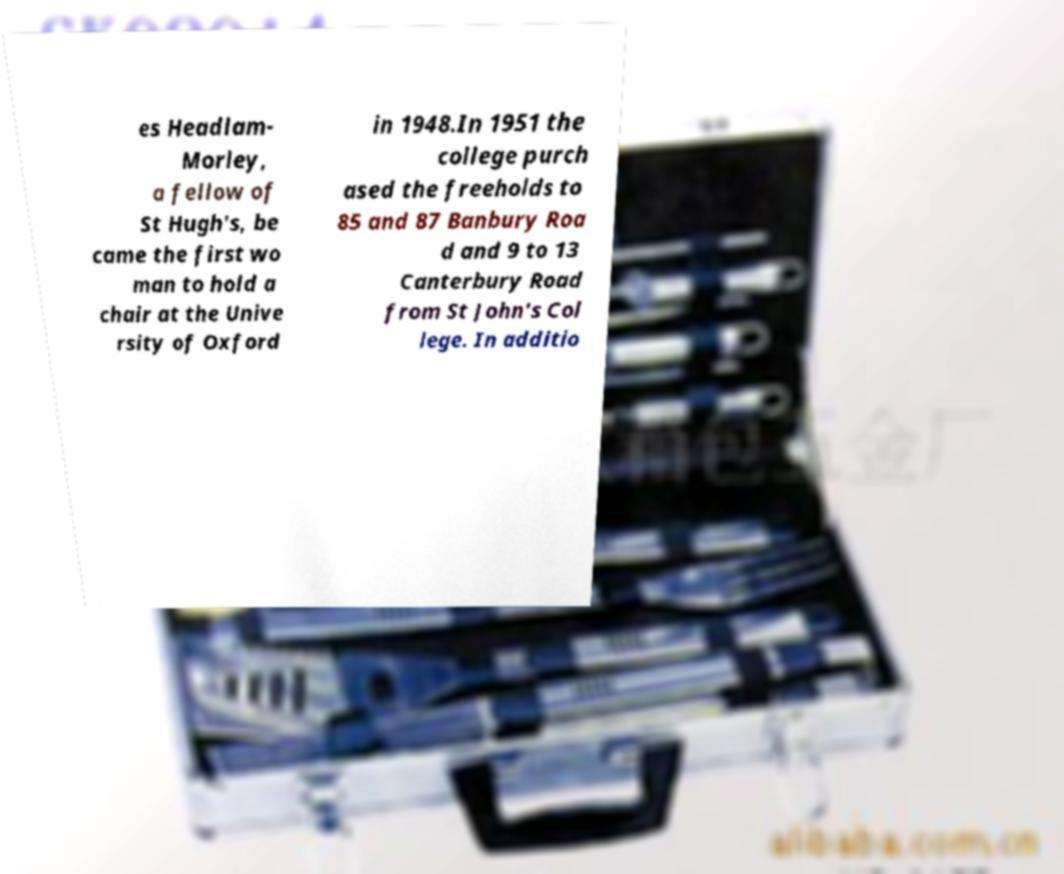What messages or text are displayed in this image? I need them in a readable, typed format. es Headlam- Morley, a fellow of St Hugh's, be came the first wo man to hold a chair at the Unive rsity of Oxford in 1948.In 1951 the college purch ased the freeholds to 85 and 87 Banbury Roa d and 9 to 13 Canterbury Road from St John's Col lege. In additio 